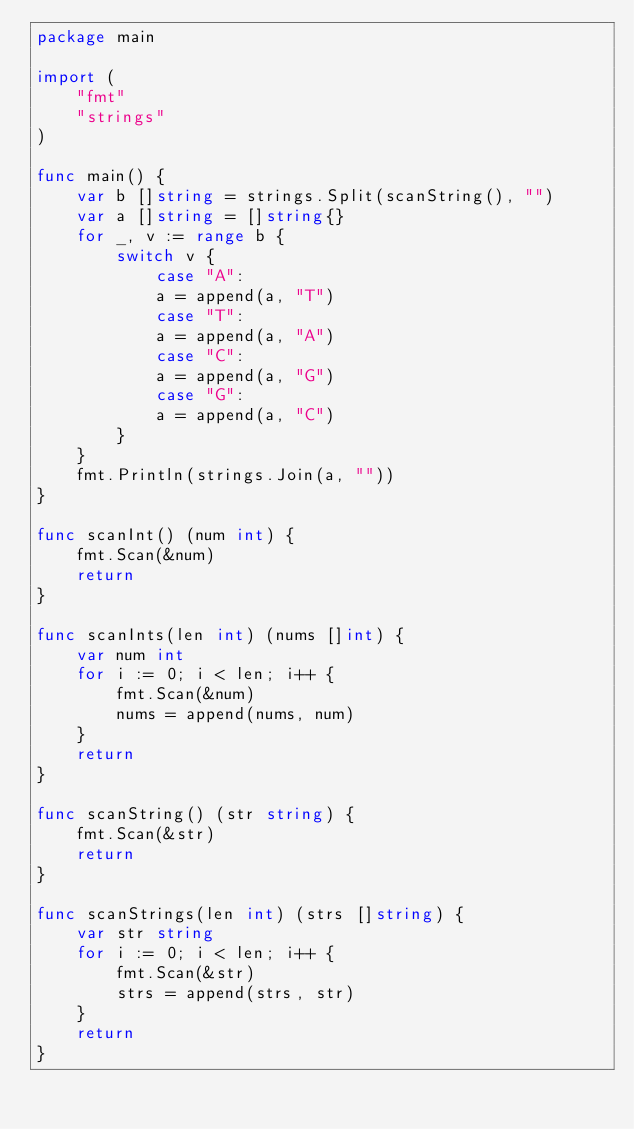Convert code to text. <code><loc_0><loc_0><loc_500><loc_500><_Go_>package main

import (
    "fmt"
    "strings"
)

func main() {
    var b []string = strings.Split(scanString(), "")
    var a []string = []string{}
    for _, v := range b {
        switch v {
            case "A":
            a = append(a, "T")
            case "T":
            a = append(a, "A")
            case "C":
            a = append(a, "G")
            case "G":
            a = append(a, "C")
        }
    }
    fmt.Println(strings.Join(a, ""))
}

func scanInt() (num int) {
    fmt.Scan(&num)
    return
}

func scanInts(len int) (nums []int) {
    var num int
    for i := 0; i < len; i++ {
        fmt.Scan(&num)
        nums = append(nums, num)
    }
    return
}

func scanString() (str string) {
    fmt.Scan(&str)
    return
}

func scanStrings(len int) (strs []string) {
    var str string
    for i := 0; i < len; i++ {
        fmt.Scan(&str)
        strs = append(strs, str)
    }
    return
}</code> 